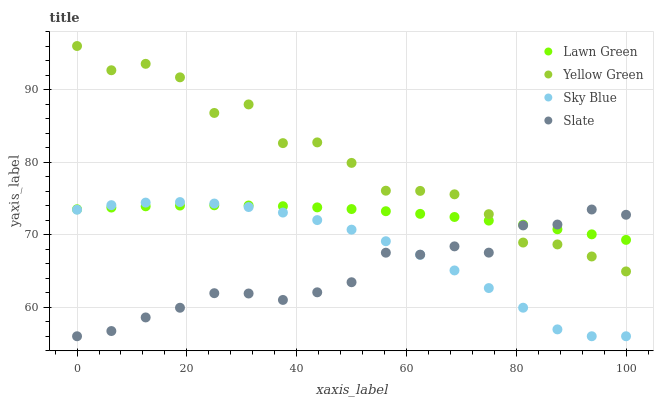Does Slate have the minimum area under the curve?
Answer yes or no. Yes. Does Yellow Green have the maximum area under the curve?
Answer yes or no. Yes. Does Yellow Green have the minimum area under the curve?
Answer yes or no. No. Does Slate have the maximum area under the curve?
Answer yes or no. No. Is Lawn Green the smoothest?
Answer yes or no. Yes. Is Yellow Green the roughest?
Answer yes or no. Yes. Is Slate the smoothest?
Answer yes or no. No. Is Slate the roughest?
Answer yes or no. No. Does Slate have the lowest value?
Answer yes or no. Yes. Does Yellow Green have the lowest value?
Answer yes or no. No. Does Yellow Green have the highest value?
Answer yes or no. Yes. Does Slate have the highest value?
Answer yes or no. No. Is Sky Blue less than Yellow Green?
Answer yes or no. Yes. Is Yellow Green greater than Sky Blue?
Answer yes or no. Yes. Does Lawn Green intersect Slate?
Answer yes or no. Yes. Is Lawn Green less than Slate?
Answer yes or no. No. Is Lawn Green greater than Slate?
Answer yes or no. No. Does Sky Blue intersect Yellow Green?
Answer yes or no. No. 